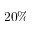<formula> <loc_0><loc_0><loc_500><loc_500>2 0 \%</formula> 